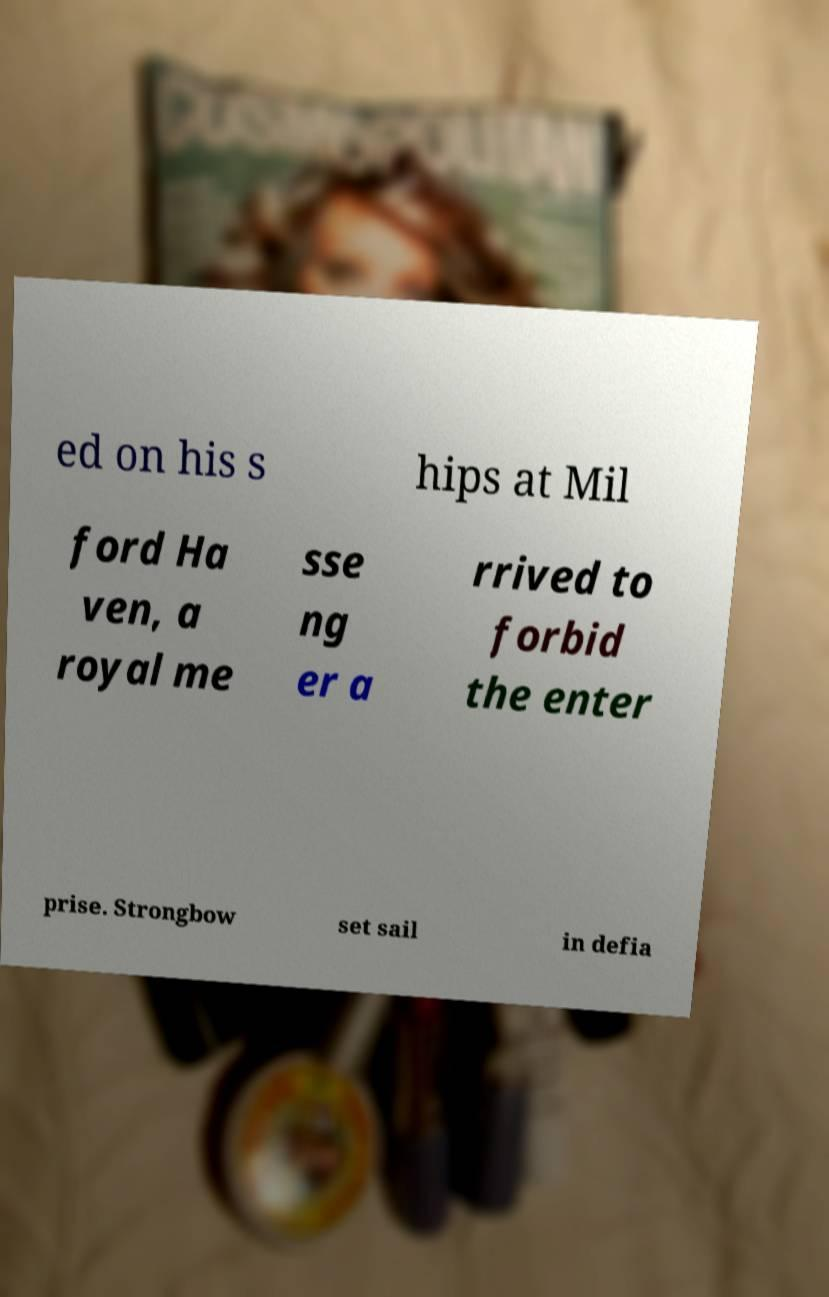I need the written content from this picture converted into text. Can you do that? ed on his s hips at Mil ford Ha ven, a royal me sse ng er a rrived to forbid the enter prise. Strongbow set sail in defia 